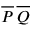Convert formula to latex. <formula><loc_0><loc_0><loc_500><loc_500>{ \overline { P } } \, { \overline { Q } }</formula> 